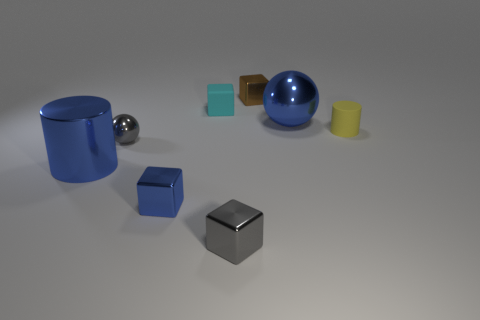Does the thing that is to the right of the big ball have the same shape as the tiny matte thing on the left side of the small yellow rubber cylinder?
Your answer should be very brief. No. What is the color of the big thing on the right side of the cylinder that is to the left of the cyan rubber thing?
Your response must be concise. Blue. What number of cylinders are tiny rubber things or tiny blue metal things?
Provide a succinct answer. 1. How many blue metallic cubes are in front of the gray metal thing behind the big blue thing that is left of the matte cube?
Give a very brief answer. 1. What is the size of the metallic ball that is the same color as the large shiny cylinder?
Offer a very short reply. Large. Is there a green cylinder that has the same material as the small gray ball?
Provide a short and direct response. No. Is the material of the small gray cube the same as the tiny cyan block?
Your answer should be compact. No. What number of big blue metallic spheres are on the left side of the big blue thing that is in front of the blue metallic ball?
Ensure brevity in your answer.  0. How many yellow things are either rubber things or small objects?
Provide a succinct answer. 1. What shape is the large shiny object that is to the left of the large shiny object that is right of the small object that is left of the small blue shiny object?
Keep it short and to the point. Cylinder. 